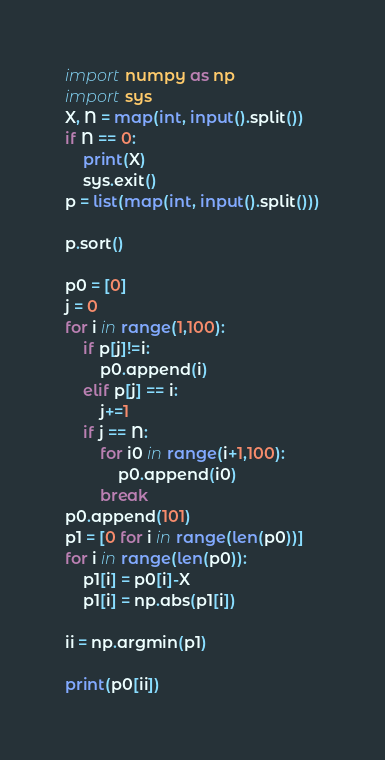<code> <loc_0><loc_0><loc_500><loc_500><_Python_>import numpy as np
import sys
X, N = map(int, input().split())
if N == 0:
    print(X)
    sys.exit()
p = list(map(int, input().split()))

p.sort()

p0 = [0]
j = 0
for i in range(1,100):
    if p[j]!=i:
        p0.append(i)
    elif p[j] == i:
        j+=1
    if j == N:
        for i0 in range(i+1,100):
            p0.append(i0)
        break
p0.append(101)
p1 = [0 for i in range(len(p0))]
for i in range(len(p0)):
    p1[i] = p0[i]-X
    p1[i] = np.abs(p1[i])
    
ii = np.argmin(p1)

print(p0[ii])</code> 